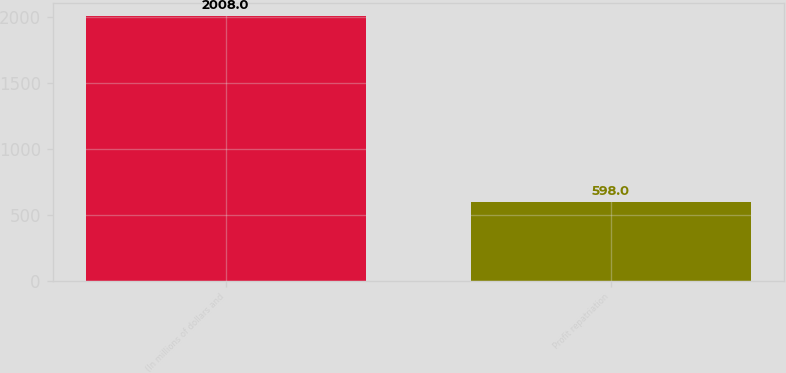Convert chart. <chart><loc_0><loc_0><loc_500><loc_500><bar_chart><fcel>(In millions of dollars and<fcel>Profit repatriation<nl><fcel>2008<fcel>598<nl></chart> 